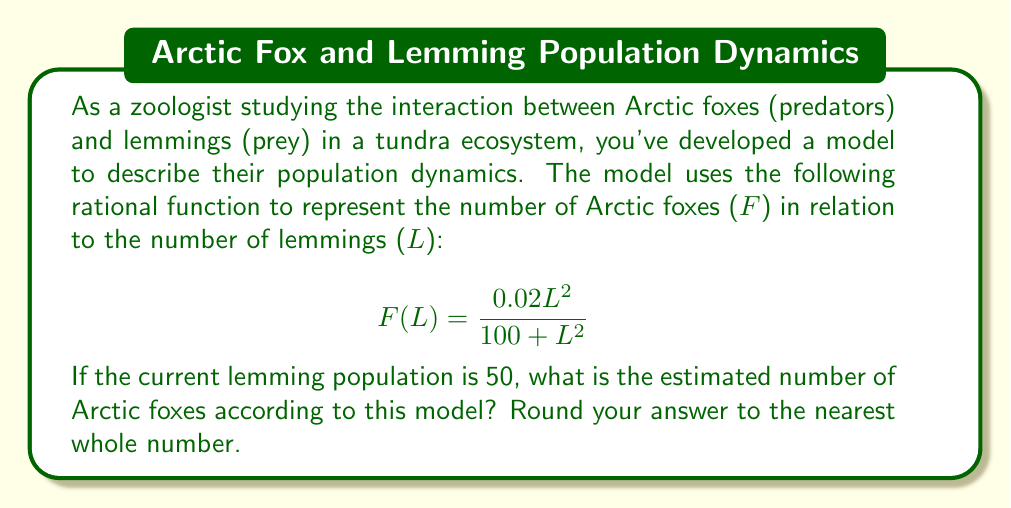Help me with this question. To solve this problem, we need to follow these steps:

1. Identify the given information:
   - The rational function model: $F(L) = \frac{0.02L^2}{100 + L^2}$
   - Current lemming population: $L = 50$

2. Substitute the lemming population value into the function:
   $$F(50) = \frac{0.02(50)^2}{100 + (50)^2}$$

3. Calculate the numerator:
   $0.02(50)^2 = 0.02 \times 2500 = 50$

4. Calculate the denominator:
   $100 + (50)^2 = 100 + 2500 = 2600$

5. Simplify the fraction:
   $$F(50) = \frac{50}{2600}$$

6. Perform the division:
   $$F(50) = 0.01923076923...$$

7. Round to the nearest whole number:
   $F(50) \approx 2$

Therefore, when the lemming population is 50, the model estimates approximately 2 Arctic foxes in the ecosystem.
Answer: 2 Arctic foxes 